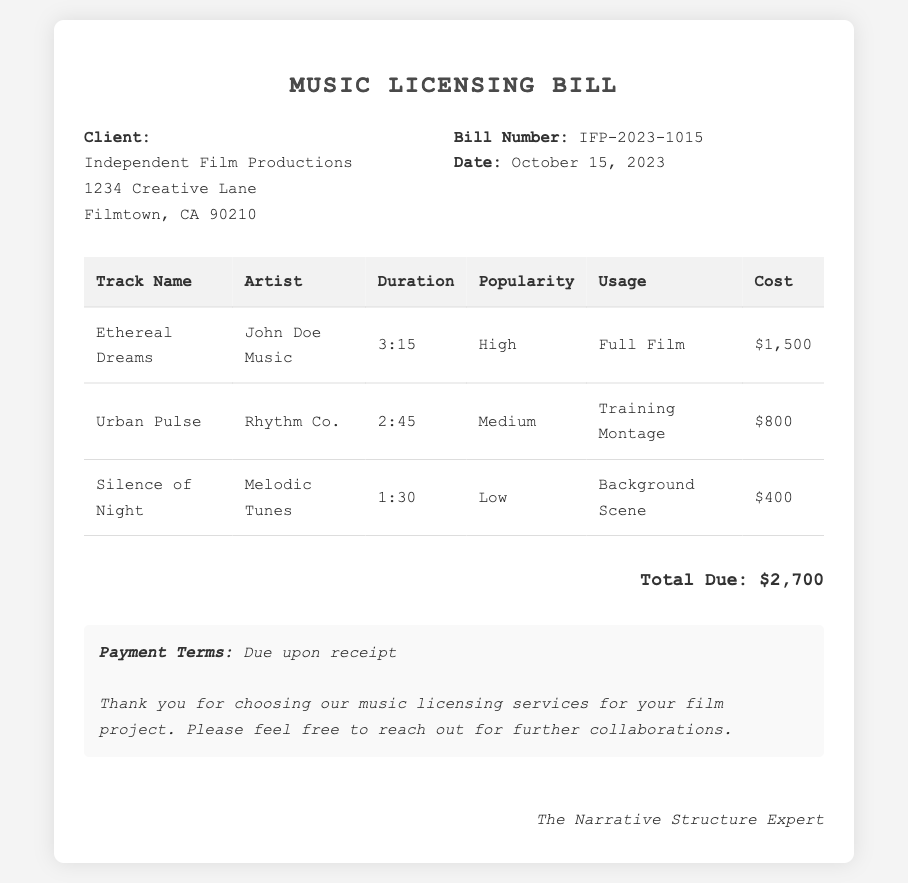What is the bill number? The bill number can be found under the bill information section, which states "IFP-2023-1015".
Answer: IFP-2023-1015 What is the date of the bill? The date listed in the bill information section indicates when the bill was issued, which is "October 15, 2023".
Answer: October 15, 2023 Who is the client? The client information section identifies "Independent Film Productions" as the client.
Answer: Independent Film Productions What is the total due amount? The total amount due is summarized at the bottom of the document, which states "Total Due: $2,700".
Answer: $2,700 How many tracks are listed in the document? The document contains a table that lists three tracks, as evident from the number of rows in the table.
Answer: 3 Which track has the highest cost? By examining the costs listed for each track, "Ethereal Dreams" has the highest cost at "$1,500".
Answer: Ethereal Dreams What usage is specified for "Silence of Night"? The usage specified in the table for "Silence of Night" is found in the corresponding column, stating "Background Scene".
Answer: Background Scene What popularity level is assigned to "Urban Pulse"? The popularity level for "Urban Pulse" is indicated as "Medium" in the relevant column of the table.
Answer: Medium Who signed the document? The signature at the bottom of the document identifies the signatory as "The Narrative Structure Expert".
Answer: The Narrative Structure Expert 